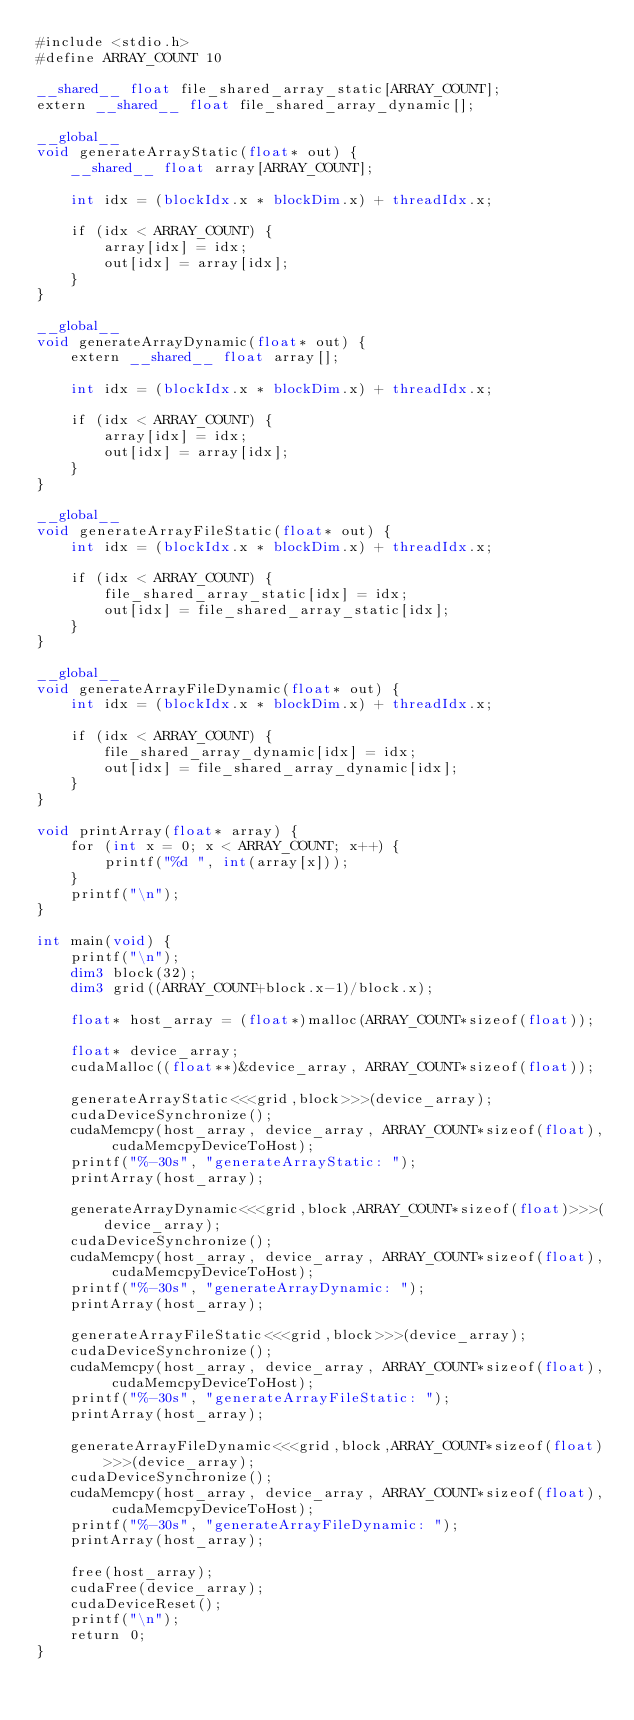Convert code to text. <code><loc_0><loc_0><loc_500><loc_500><_Cuda_>#include <stdio.h>
#define ARRAY_COUNT 10

__shared__ float file_shared_array_static[ARRAY_COUNT];
extern __shared__ float file_shared_array_dynamic[];

__global__
void generateArrayStatic(float* out) {
	__shared__ float array[ARRAY_COUNT];

	int idx = (blockIdx.x * blockDim.x) + threadIdx.x;

	if (idx < ARRAY_COUNT) {
		array[idx] = idx;
		out[idx] = array[idx];
	}
}

__global__
void generateArrayDynamic(float* out) {
	extern __shared__ float array[];

	int idx = (blockIdx.x * blockDim.x) + threadIdx.x;

	if (idx < ARRAY_COUNT) {
		array[idx] = idx;
		out[idx] = array[idx];
	}
}

__global__
void generateArrayFileStatic(float* out) {
	int idx = (blockIdx.x * blockDim.x) + threadIdx.x;

	if (idx < ARRAY_COUNT) {
		file_shared_array_static[idx] = idx;
		out[idx] = file_shared_array_static[idx];
	}
}

__global__
void generateArrayFileDynamic(float* out) {
	int idx = (blockIdx.x * blockDim.x) + threadIdx.x;

	if (idx < ARRAY_COUNT) {
		file_shared_array_dynamic[idx] = idx;
		out[idx] = file_shared_array_dynamic[idx];
	}
}

void printArray(float* array) {
	for (int x = 0; x < ARRAY_COUNT; x++) {
		printf("%d ", int(array[x]));
	}
	printf("\n");
}

int main(void) {
	printf("\n");
	dim3 block(32);
	dim3 grid((ARRAY_COUNT+block.x-1)/block.x);

	float* host_array = (float*)malloc(ARRAY_COUNT*sizeof(float));

	float* device_array;
	cudaMalloc((float**)&device_array, ARRAY_COUNT*sizeof(float));

	generateArrayStatic<<<grid,block>>>(device_array);
	cudaDeviceSynchronize();
	cudaMemcpy(host_array, device_array, ARRAY_COUNT*sizeof(float), cudaMemcpyDeviceToHost);
	printf("%-30s", "generateArrayStatic: ");
	printArray(host_array);

	generateArrayDynamic<<<grid,block,ARRAY_COUNT*sizeof(float)>>>(device_array);
	cudaDeviceSynchronize();
	cudaMemcpy(host_array, device_array, ARRAY_COUNT*sizeof(float), cudaMemcpyDeviceToHost);
	printf("%-30s", "generateArrayDynamic: ");
	printArray(host_array);

	generateArrayFileStatic<<<grid,block>>>(device_array);
	cudaDeviceSynchronize();
	cudaMemcpy(host_array, device_array, ARRAY_COUNT*sizeof(float), cudaMemcpyDeviceToHost);
	printf("%-30s", "generateArrayFileStatic: ");
	printArray(host_array);

	generateArrayFileDynamic<<<grid,block,ARRAY_COUNT*sizeof(float)>>>(device_array);
	cudaDeviceSynchronize();
	cudaMemcpy(host_array, device_array, ARRAY_COUNT*sizeof(float), cudaMemcpyDeviceToHost);
	printf("%-30s", "generateArrayFileDynamic: ");
	printArray(host_array);

	free(host_array);
	cudaFree(device_array);
	cudaDeviceReset();
	printf("\n");
	return 0;
}</code> 